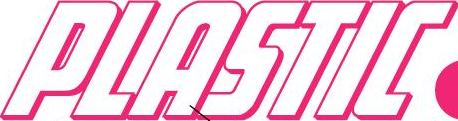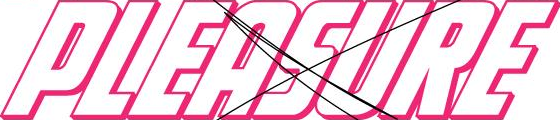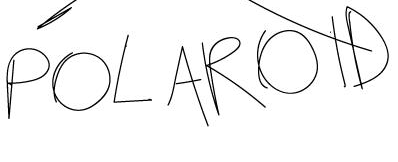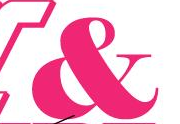Transcribe the words shown in these images in order, separated by a semicolon. PLASTIC; PLEASURE; POLAROID; & 